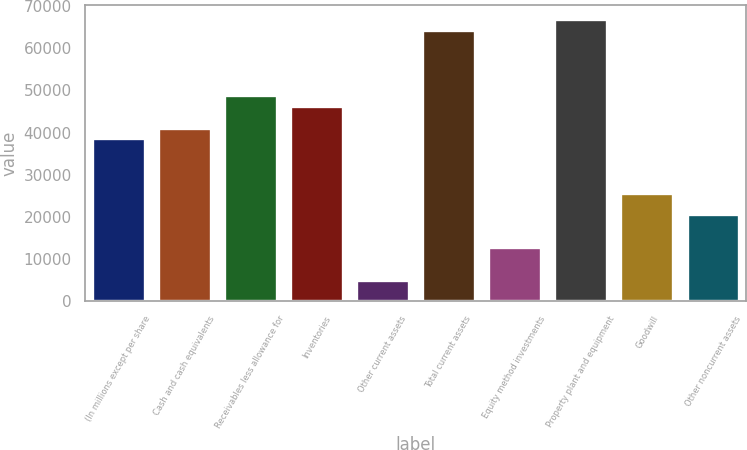Convert chart. <chart><loc_0><loc_0><loc_500><loc_500><bar_chart><fcel>(In millions except per share<fcel>Cash and cash equivalents<fcel>Receivables less allowance for<fcel>Inventories<fcel>Other current assets<fcel>Total current assets<fcel>Equity method investments<fcel>Property plant and equipment<fcel>Goodwill<fcel>Other noncurrent assets<nl><fcel>38615.5<fcel>41189.6<fcel>48911.9<fcel>46337.8<fcel>5152.2<fcel>64356.5<fcel>12874.5<fcel>66930.6<fcel>25745<fcel>20596.8<nl></chart> 